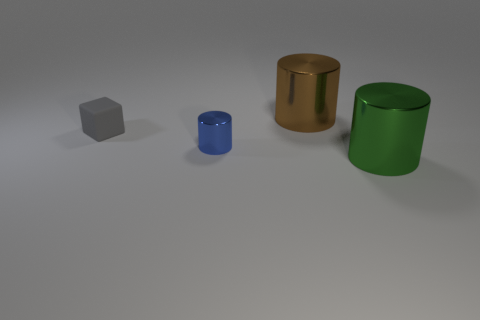Subtract all big cylinders. How many cylinders are left? 1 Add 1 tiny gray cubes. How many objects exist? 5 Subtract all blocks. How many objects are left? 3 Subtract all blue things. Subtract all big brown cylinders. How many objects are left? 2 Add 3 big brown cylinders. How many big brown cylinders are left? 4 Add 1 tiny cyan cubes. How many tiny cyan cubes exist? 1 Subtract 0 gray balls. How many objects are left? 4 